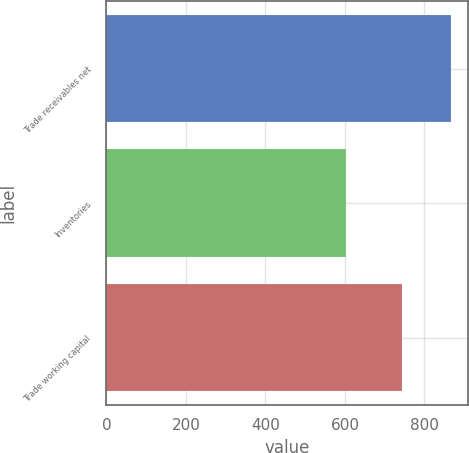Convert chart. <chart><loc_0><loc_0><loc_500><loc_500><bar_chart><fcel>Trade receivables net<fcel>Inventories<fcel>Trade working capital<nl><fcel>866<fcel>603<fcel>743<nl></chart> 